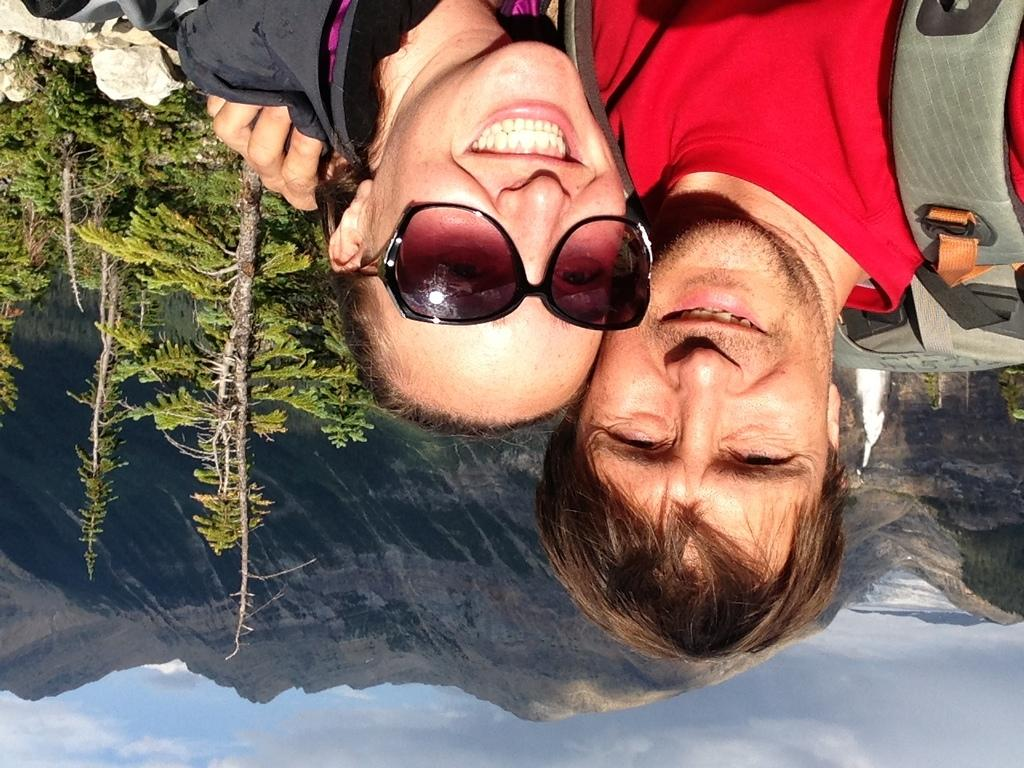How many people are in the image? There are two persons in the image. What is located to the left of the image? There are trees to the left of the image. What is present to the top left of the image? There are rocks to the top left of the image. What is visible at the bottom of the image? There is a sky at the bottom of the image. What can be seen in the background of the image? There are mountains in the background of the image. How many sticks are being used by the persons in the image? There are no sticks visible in the image. What type of clam is present in the image? There are no clams present in the image. 